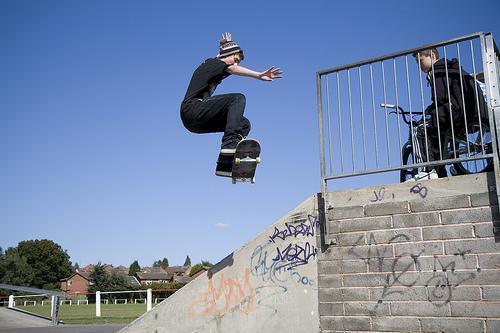How many people are in this picture?
Give a very brief answer. 2. 